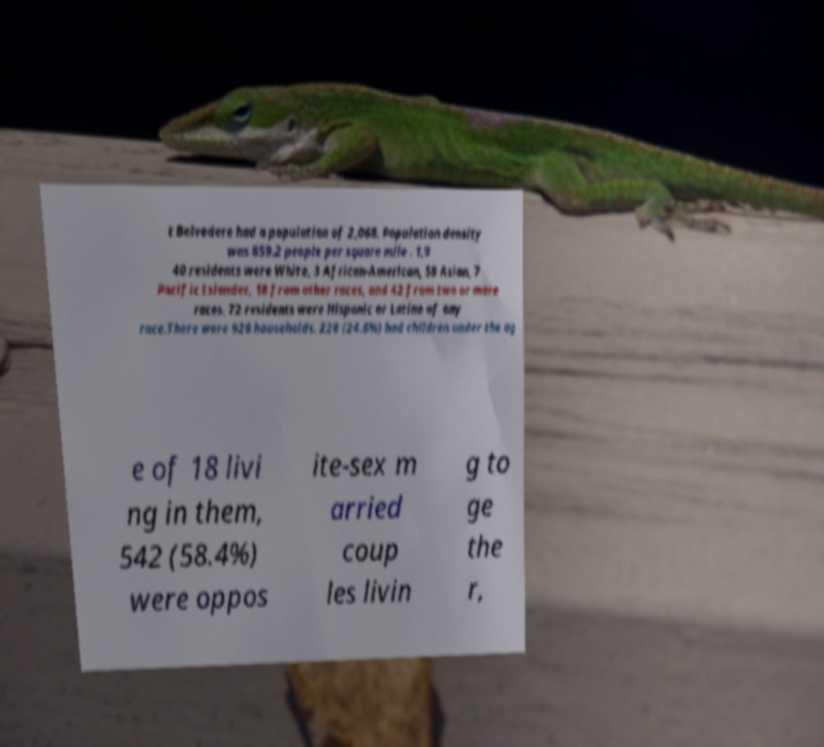Can you read and provide the text displayed in the image?This photo seems to have some interesting text. Can you extract and type it out for me? t Belvedere had a population of 2,068. Population density was 859.2 people per square mile . 1,9 40 residents were White, 3 African-American, 58 Asian, 7 Pacific Islander, 18 from other races, and 42 from two or more races. 72 residents were Hispanic or Latino of any race.There were 928 households. 228 (24.6%) had children under the ag e of 18 livi ng in them, 542 (58.4%) were oppos ite-sex m arried coup les livin g to ge the r, 